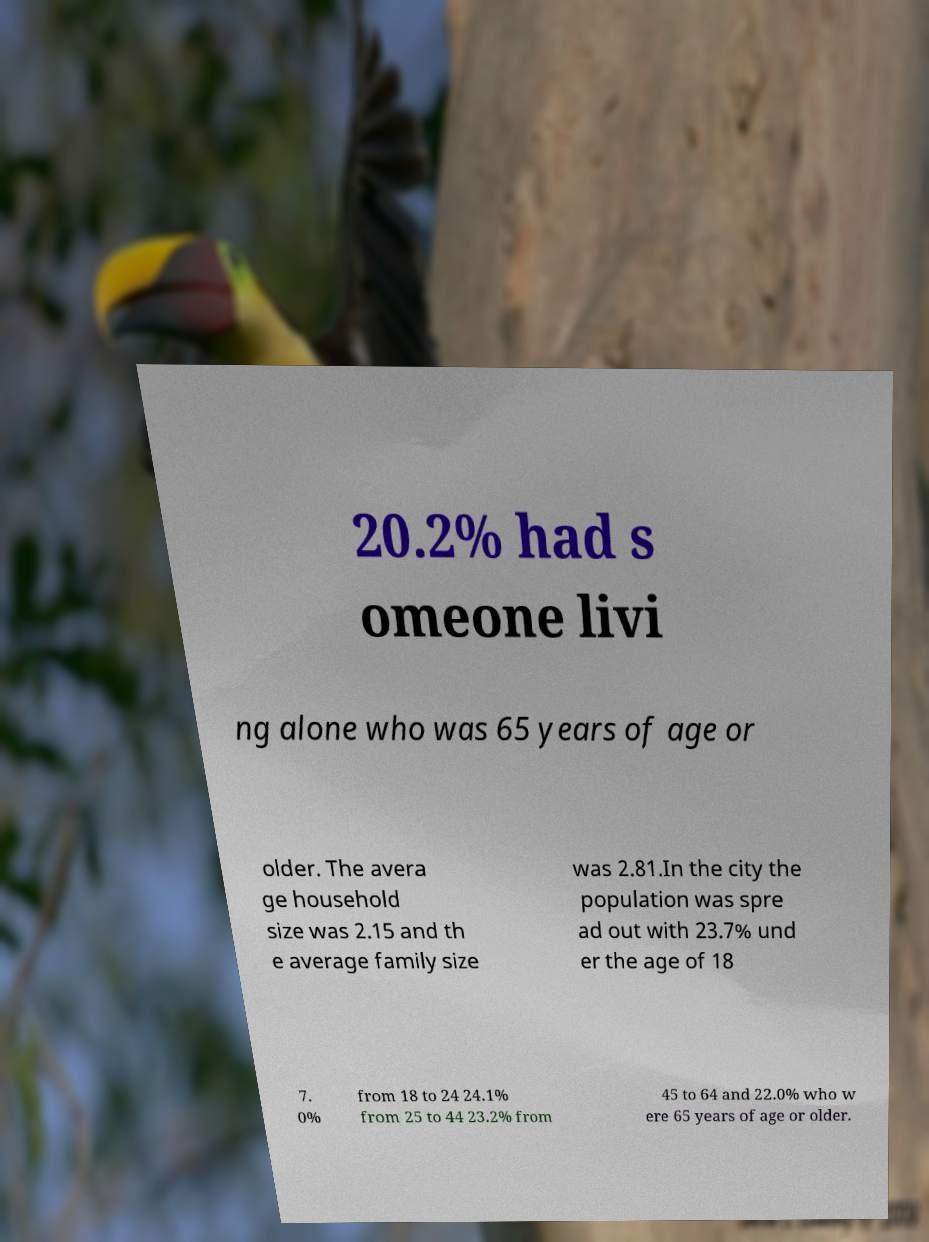For documentation purposes, I need the text within this image transcribed. Could you provide that? 20.2% had s omeone livi ng alone who was 65 years of age or older. The avera ge household size was 2.15 and th e average family size was 2.81.In the city the population was spre ad out with 23.7% und er the age of 18 7. 0% from 18 to 24 24.1% from 25 to 44 23.2% from 45 to 64 and 22.0% who w ere 65 years of age or older. 